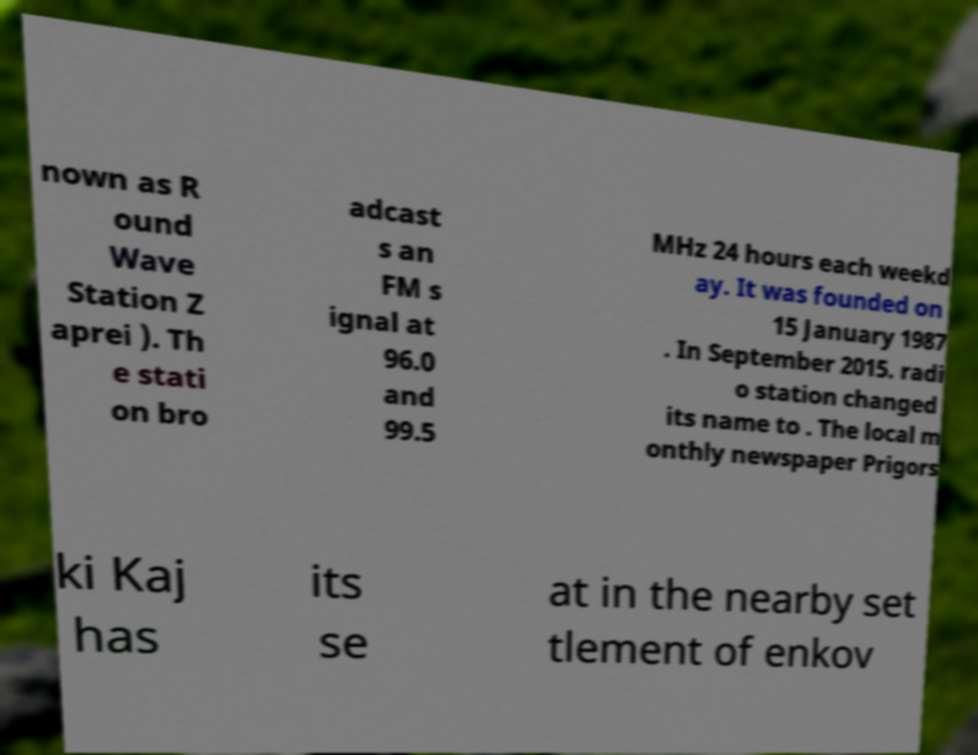Could you assist in decoding the text presented in this image and type it out clearly? nown as R ound Wave Station Z aprei ). Th e stati on bro adcast s an FM s ignal at 96.0 and 99.5 MHz 24 hours each weekd ay. It was founded on 15 January 1987 . In September 2015. radi o station changed its name to . The local m onthly newspaper Prigors ki Kaj has its se at in the nearby set tlement of enkov 